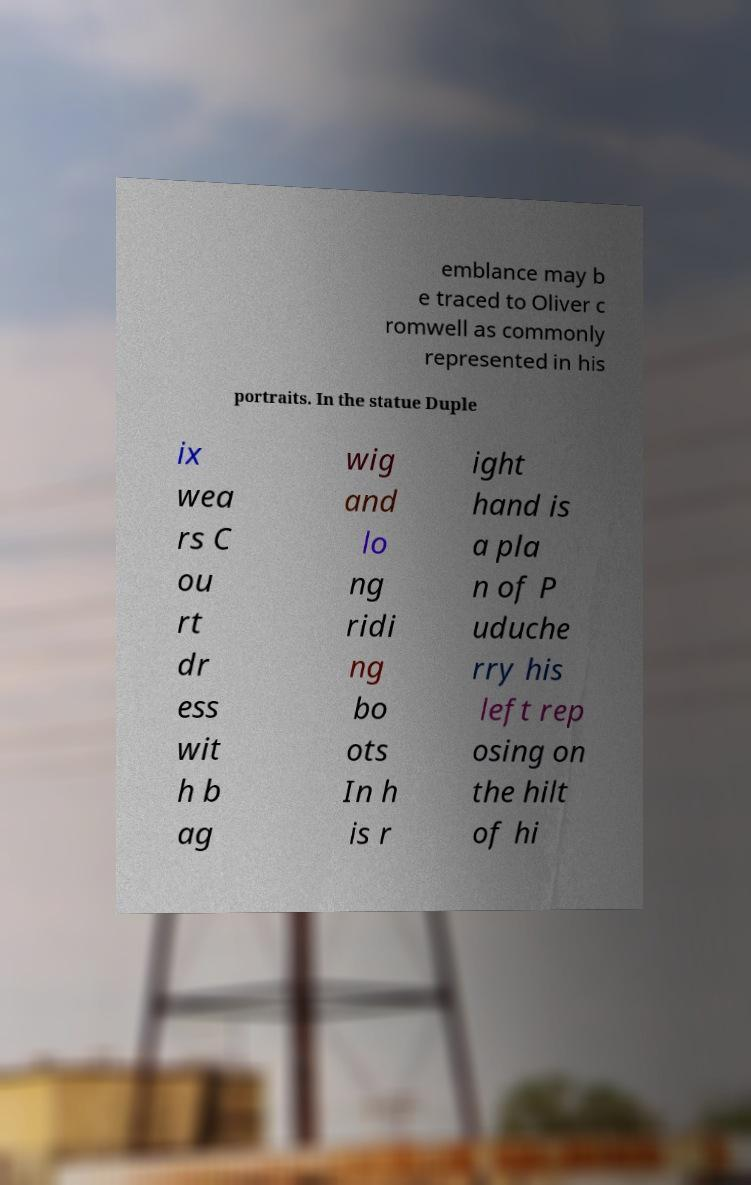Please identify and transcribe the text found in this image. emblance may b e traced to Oliver c romwell as commonly represented in his portraits. In the statue Duple ix wea rs C ou rt dr ess wit h b ag wig and lo ng ridi ng bo ots In h is r ight hand is a pla n of P uduche rry his left rep osing on the hilt of hi 